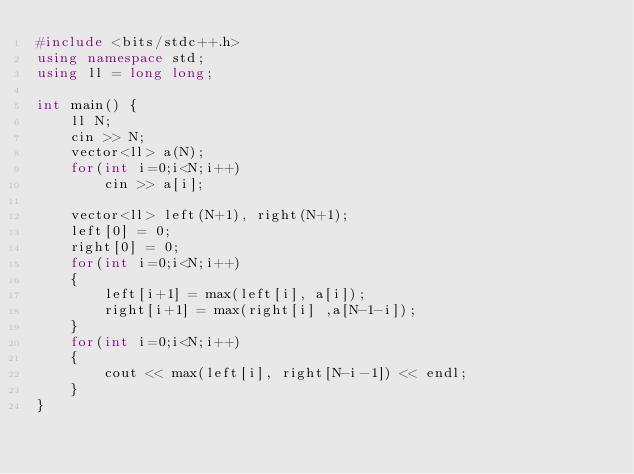Convert code to text. <code><loc_0><loc_0><loc_500><loc_500><_C++_>#include <bits/stdc++.h>
using namespace std;
using ll = long long;

int main() {
	ll N;
	cin >> N;
	vector<ll> a(N);
	for(int i=0;i<N;i++)
		cin >> a[i];
	
	vector<ll> left(N+1), right(N+1);
	left[0] = 0;
	right[0] = 0;
	for(int i=0;i<N;i++)
	{
		left[i+1] = max(left[i], a[i]);
		right[i+1] = max(right[i] ,a[N-1-i]);
	}
	for(int i=0;i<N;i++)
	{
		cout << max(left[i], right[N-i-1]) << endl;
	}
}</code> 